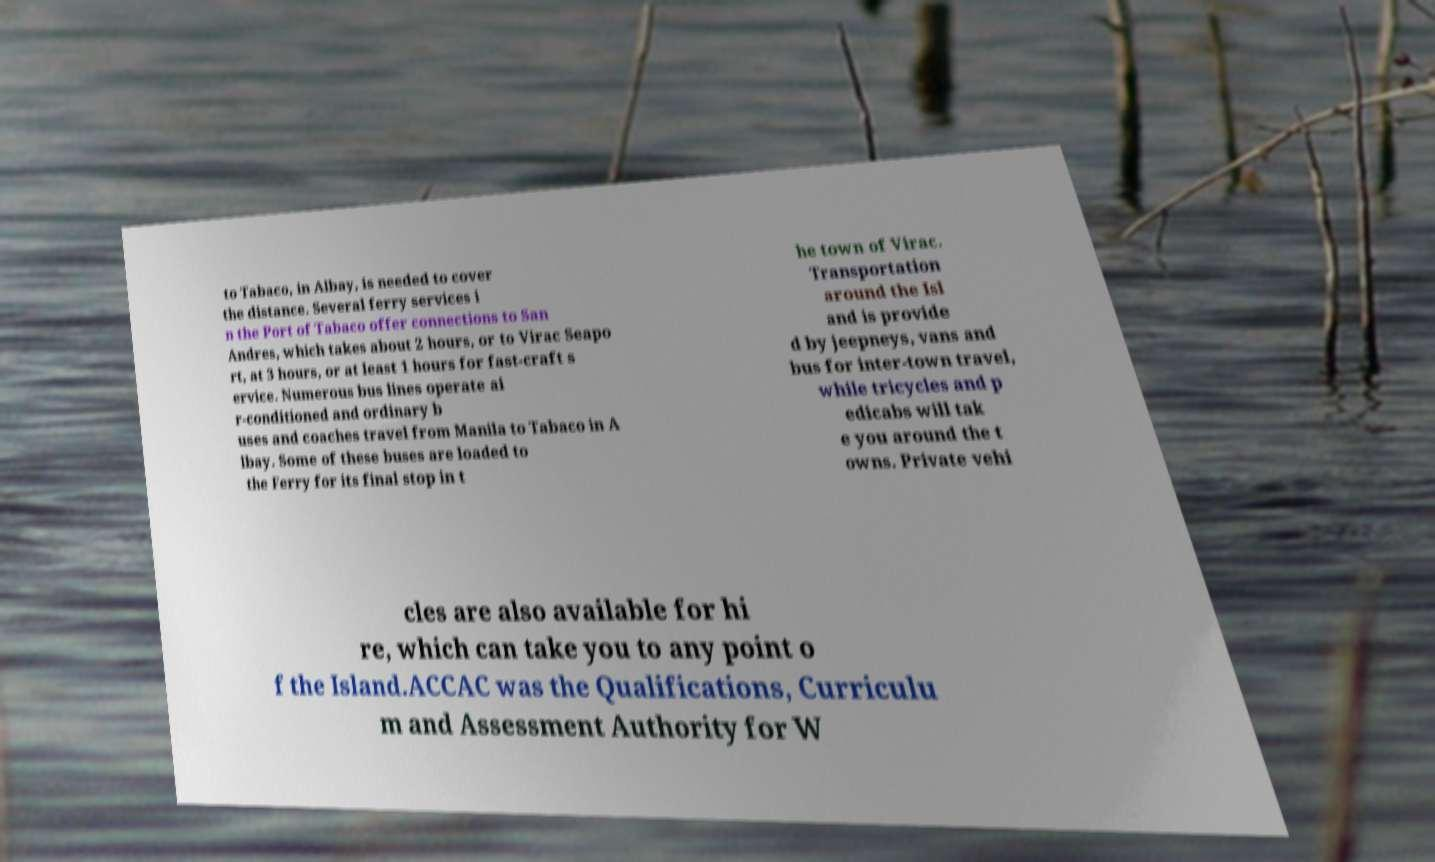For documentation purposes, I need the text within this image transcribed. Could you provide that? to Tabaco, in Albay, is needed to cover the distance. Several ferry services i n the Port of Tabaco offer connections to San Andres, which takes about 2 hours, or to Virac Seapo rt, at 3 hours, or at least 1 hours for fast-craft s ervice. Numerous bus lines operate ai r-conditioned and ordinary b uses and coaches travel from Manila to Tabaco in A lbay. Some of these buses are loaded to the Ferry for its final stop in t he town of Virac. Transportation around the Isl and is provide d by jeepneys, vans and bus for inter-town travel, while tricycles and p edicabs will tak e you around the t owns. Private vehi cles are also available for hi re, which can take you to any point o f the Island.ACCAC was the Qualifications, Curriculu m and Assessment Authority for W 